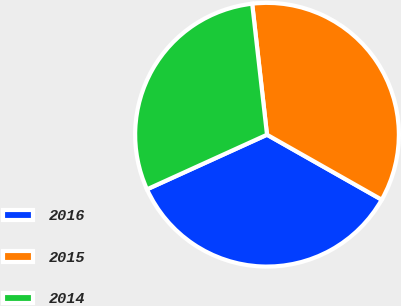Convert chart. <chart><loc_0><loc_0><loc_500><loc_500><pie_chart><fcel>2016<fcel>2015<fcel>2014<nl><fcel>35.0%<fcel>35.0%<fcel>30.0%<nl></chart> 